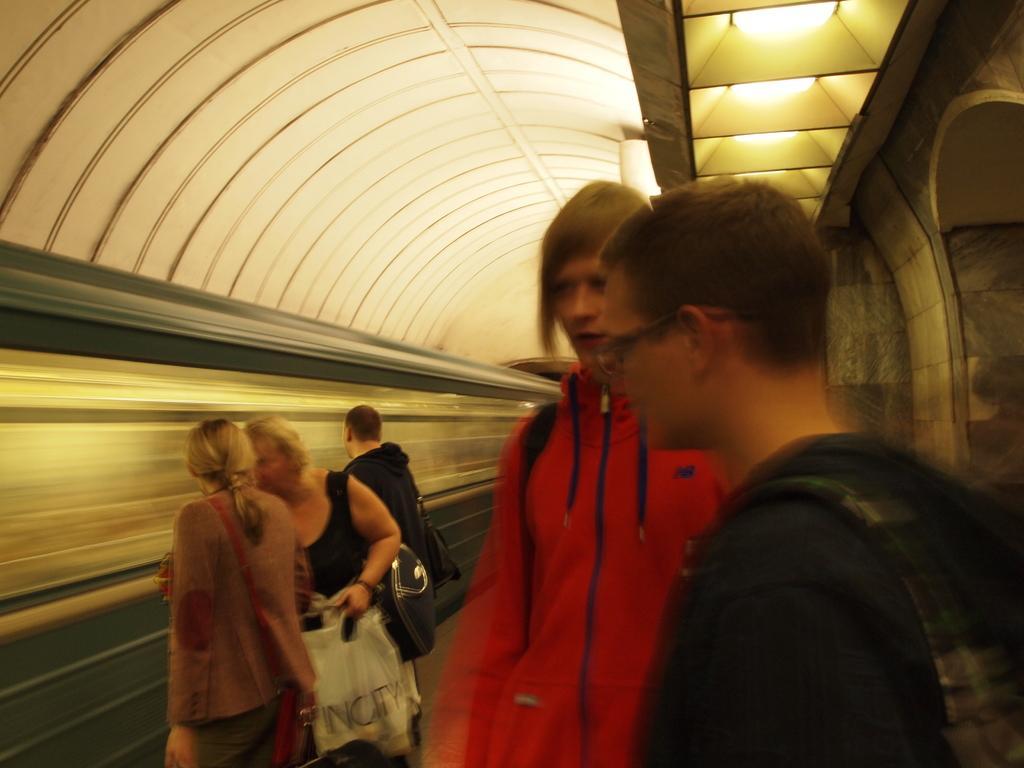Can you describe this image briefly? In this image we can see some group of persons standing on platform and there is a train which is moving and top of the image there is roof and some lights. 